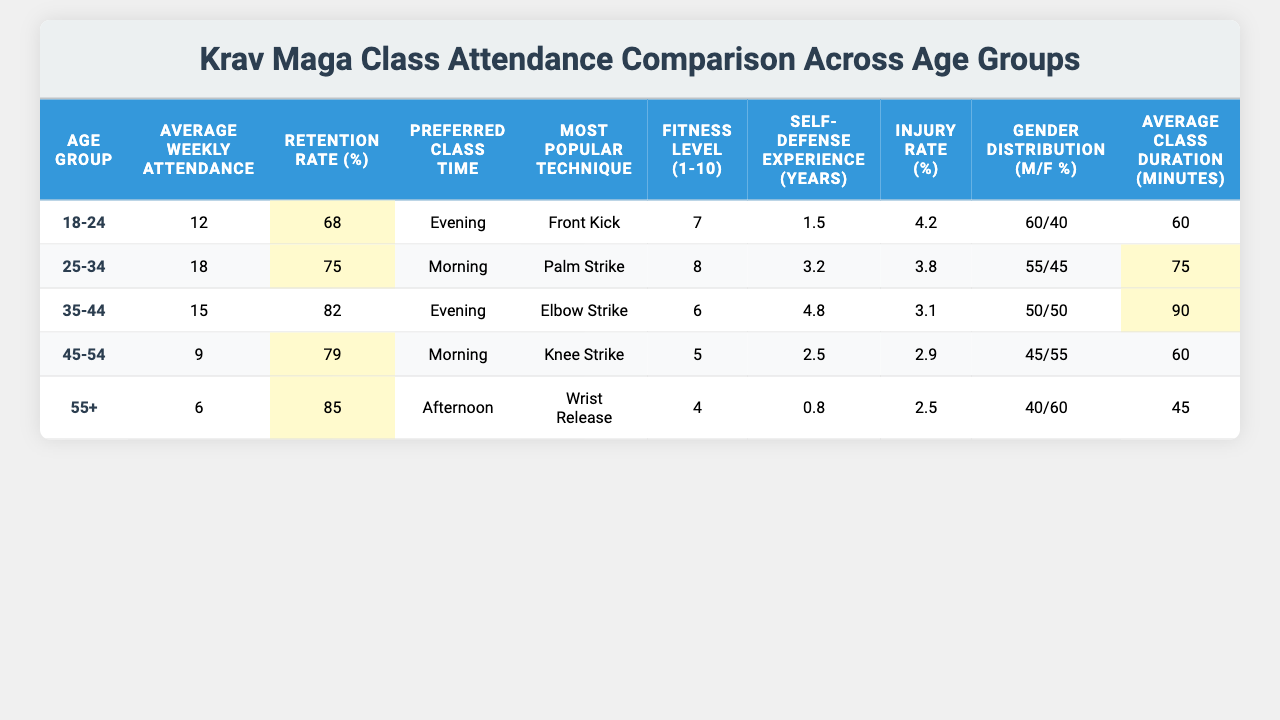What is the average weekly attendance for the age group 35-44? From the table, the average weekly attendance for the age group 35-44 is directly listed as 15.
Answer: 15 Which age group has the highest retention rate? Looking at the retention rates in the table, the group 55+ has the highest rate at 85%.
Answer: 55+ What is the preferred class time for individuals aged 25-34? According to the table, individuals aged 25-34 prefer morning classes.
Answer: Morning If you compare the average weekly attendance of the youngest age group to the oldest, what is the difference? The average weekly attendance for the youngest age group (18-24) is 12, and for the oldest (55+) is 6. The difference is 12 - 6 = 6.
Answer: 6 What is the average fitness level across all age groups? To calculate the average fitness level, we sum the fitness levels: 7 + 8 + 6 + 5 + 4 = 30, then divide by the number of age groups (5), giving us 30/5 = 6.
Answer: 6 Does the injury rate decrease as the age group increases? By comparing the injury rates, we see that the rates go from 4.2% (18-24) to 2.5% (55+), meaning it does decrease.
Answer: Yes Among all age groups, which technique is most popular and for which age group? The table shows that the most popular technique is the front kick for the age group 18-24.
Answer: Front Kick; 18-24 Which age group has the shortest average class duration? By inspecting the average class duration, the age group 55+ has the shortest duration at 45 minutes.
Answer: 55+ Is the gender distribution of the 45-54 age group more skewed towards females or males? The gender distribution for the 45-54 age group is 45% male and 55% female, indicating it is skewed towards females.
Answer: Females What is the average self-defense experience of all age groups combined? To find the average self-defense experience, add up the years of experience: 1.5 + 3.2 + 4.8 + 2.5 + 0.8 = 12.8, then divide by 5, resulting in 12.8/5 = 2.56 years.
Answer: 2.56 years 